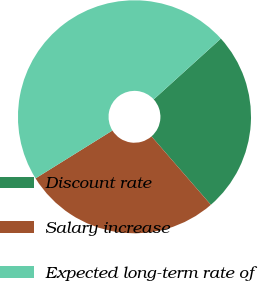Convert chart. <chart><loc_0><loc_0><loc_500><loc_500><pie_chart><fcel>Discount rate<fcel>Salary increase<fcel>Expected long-term rate of<nl><fcel>25.34%<fcel>27.52%<fcel>47.15%<nl></chart> 